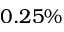Convert formula to latex. <formula><loc_0><loc_0><loc_500><loc_500>0 . 2 5 \%</formula> 